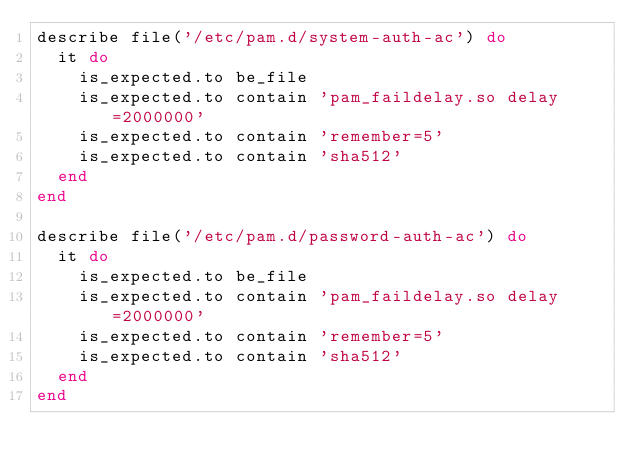<code> <loc_0><loc_0><loc_500><loc_500><_Ruby_>describe file('/etc/pam.d/system-auth-ac') do
  it do
    is_expected.to be_file
    is_expected.to contain 'pam_faildelay.so delay=2000000'
    is_expected.to contain 'remember=5'
    is_expected.to contain 'sha512'
  end
end

describe file('/etc/pam.d/password-auth-ac') do
  it do
    is_expected.to be_file
    is_expected.to contain 'pam_faildelay.so delay=2000000'
    is_expected.to contain 'remember=5'
    is_expected.to contain 'sha512'
  end
end
</code> 